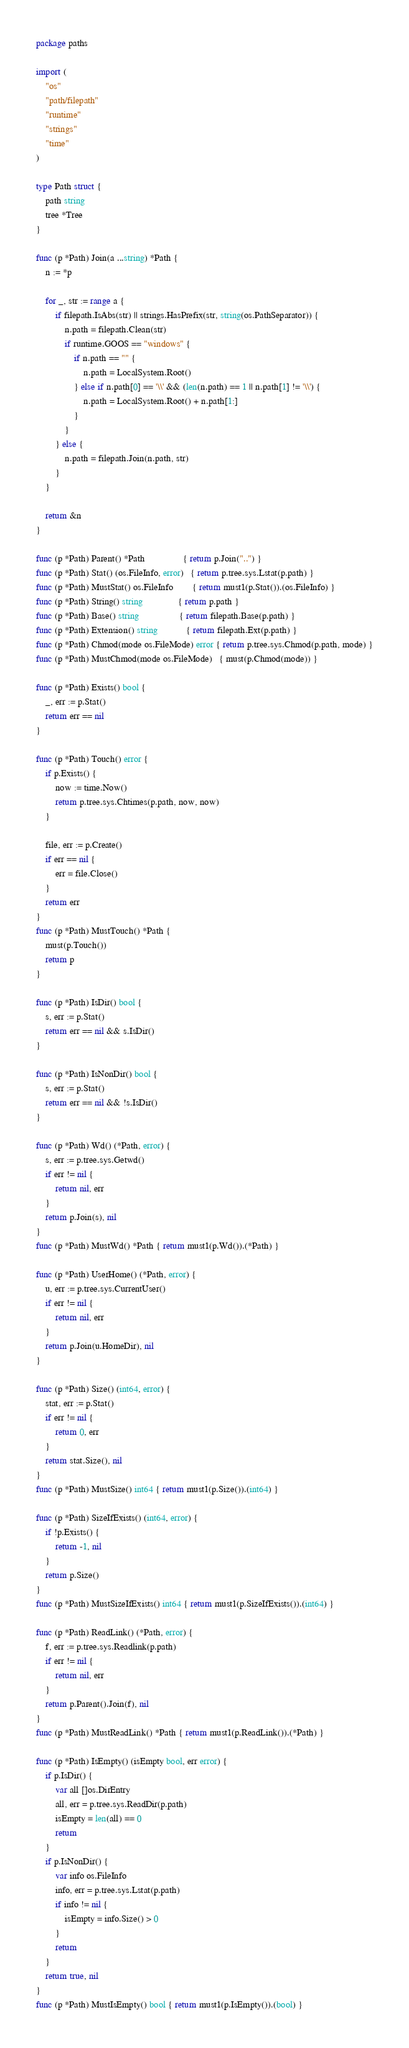Convert code to text. <code><loc_0><loc_0><loc_500><loc_500><_Go_>package paths

import (
	"os"
	"path/filepath"
	"runtime"
	"strings"
	"time"
)

type Path struct {
	path string
	tree *Tree
}

func (p *Path) Join(a ...string) *Path {
	n := *p

	for _, str := range a {
		if filepath.IsAbs(str) || strings.HasPrefix(str, string(os.PathSeparator)) {
			n.path = filepath.Clean(str)
			if runtime.GOOS == "windows" {
				if n.path == "" {
					n.path = LocalSystem.Root()
				} else if n.path[0] == '\\' && (len(n.path) == 1 || n.path[1] != '\\') {
					n.path = LocalSystem.Root() + n.path[1:]
				}
			}
		} else {
			n.path = filepath.Join(n.path, str)
		}
	}

	return &n
}

func (p *Path) Parent() *Path                { return p.Join("..") }
func (p *Path) Stat() (os.FileInfo, error)   { return p.tree.sys.Lstat(p.path) }
func (p *Path) MustStat() os.FileInfo        { return must1(p.Stat()).(os.FileInfo) }
func (p *Path) String() string               { return p.path }
func (p *Path) Base() string                 { return filepath.Base(p.path) }
func (p *Path) Extension() string            { return filepath.Ext(p.path) }
func (p *Path) Chmod(mode os.FileMode) error { return p.tree.sys.Chmod(p.path, mode) }
func (p *Path) MustChmod(mode os.FileMode)   { must(p.Chmod(mode)) }

func (p *Path) Exists() bool {
	_, err := p.Stat()
	return err == nil
}

func (p *Path) Touch() error {
	if p.Exists() {
		now := time.Now()
		return p.tree.sys.Chtimes(p.path, now, now)
	}

	file, err := p.Create()
	if err == nil {
		err = file.Close()
	}
	return err
}
func (p *Path) MustTouch() *Path {
	must(p.Touch())
	return p
}

func (p *Path) IsDir() bool {
	s, err := p.Stat()
	return err == nil && s.IsDir()
}

func (p *Path) IsNonDir() bool {
	s, err := p.Stat()
	return err == nil && !s.IsDir()
}

func (p *Path) Wd() (*Path, error) {
	s, err := p.tree.sys.Getwd()
	if err != nil {
		return nil, err
	}
	return p.Join(s), nil
}
func (p *Path) MustWd() *Path { return must1(p.Wd()).(*Path) }

func (p *Path) UserHome() (*Path, error) {
	u, err := p.tree.sys.CurrentUser()
	if err != nil {
		return nil, err
	}
	return p.Join(u.HomeDir), nil
}

func (p *Path) Size() (int64, error) {
	stat, err := p.Stat()
	if err != nil {
		return 0, err
	}
	return stat.Size(), nil
}
func (p *Path) MustSize() int64 { return must1(p.Size()).(int64) }

func (p *Path) SizeIfExists() (int64, error) {
	if !p.Exists() {
		return -1, nil
	}
	return p.Size()
}
func (p *Path) MustSizeIfExists() int64 { return must1(p.SizeIfExists()).(int64) }

func (p *Path) ReadLink() (*Path, error) {
	f, err := p.tree.sys.Readlink(p.path)
	if err != nil {
		return nil, err
	}
	return p.Parent().Join(f), nil
}
func (p *Path) MustReadLink() *Path { return must1(p.ReadLink()).(*Path) }

func (p *Path) IsEmpty() (isEmpty bool, err error) {
	if p.IsDir() {
		var all []os.DirEntry
		all, err = p.tree.sys.ReadDir(p.path)
		isEmpty = len(all) == 0
		return
	}
	if p.IsNonDir() {
		var info os.FileInfo
		info, err = p.tree.sys.Lstat(p.path)
		if info != nil {
			isEmpty = info.Size() > 0
		}
		return
	}
	return true, nil
}
func (p *Path) MustIsEmpty() bool { return must1(p.IsEmpty()).(bool) }
</code> 